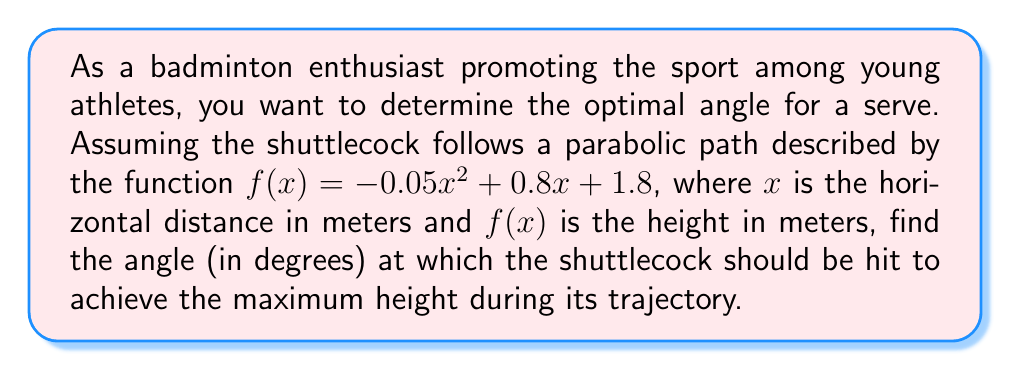What is the answer to this math problem? To find the optimal angle for the badminton serve, we need to follow these steps:

1) The function $f(x) = -0.05x^2 + 0.8x + 1.8$ is a quadratic function representing the path of the shuttlecock.

2) To find the maximum height, we need to find the vertex of this parabola. For a quadratic function in the form $f(x) = ax^2 + bx + c$, the x-coordinate of the vertex is given by $x = -\frac{b}{2a}$.

3) In this case, $a = -0.05$ and $b = 0.8$. Let's calculate the x-coordinate of the vertex:

   $x = -\frac{0.8}{2(-0.05)} = -\frac{0.8}{-0.1} = 8$ meters

4) This means the shuttlecock reaches its maximum height when it has traveled 8 meters horizontally.

5) To find the height at this point, we substitute $x = 8$ into the original function:

   $f(8) = -0.05(8)^2 + 0.8(8) + 1.8$
   $    = -0.05(64) + 6.4 + 1.8$
   $    = -3.2 + 6.4 + 1.8 = 5$ meters

6) Now we have a right triangle with the following dimensions:
   - Base (adjacent side) = 8 meters
   - Height (opposite side) = 5 - 1.8 = 3.2 meters (subtracting the initial height)

7) To find the angle, we use the arctangent function:

   $\theta = \arctan(\frac{\text{opposite}}{\text{adjacent}}) = \arctan(\frac{3.2}{8})$

8) Converting to degrees:

   $\theta = \arctan(\frac{3.2}{8}) \cdot \frac{180}{\pi} \approx 21.80^\circ$

Therefore, the optimal angle for the serve is approximately 21.80°.
Answer: $21.80^\circ$ 